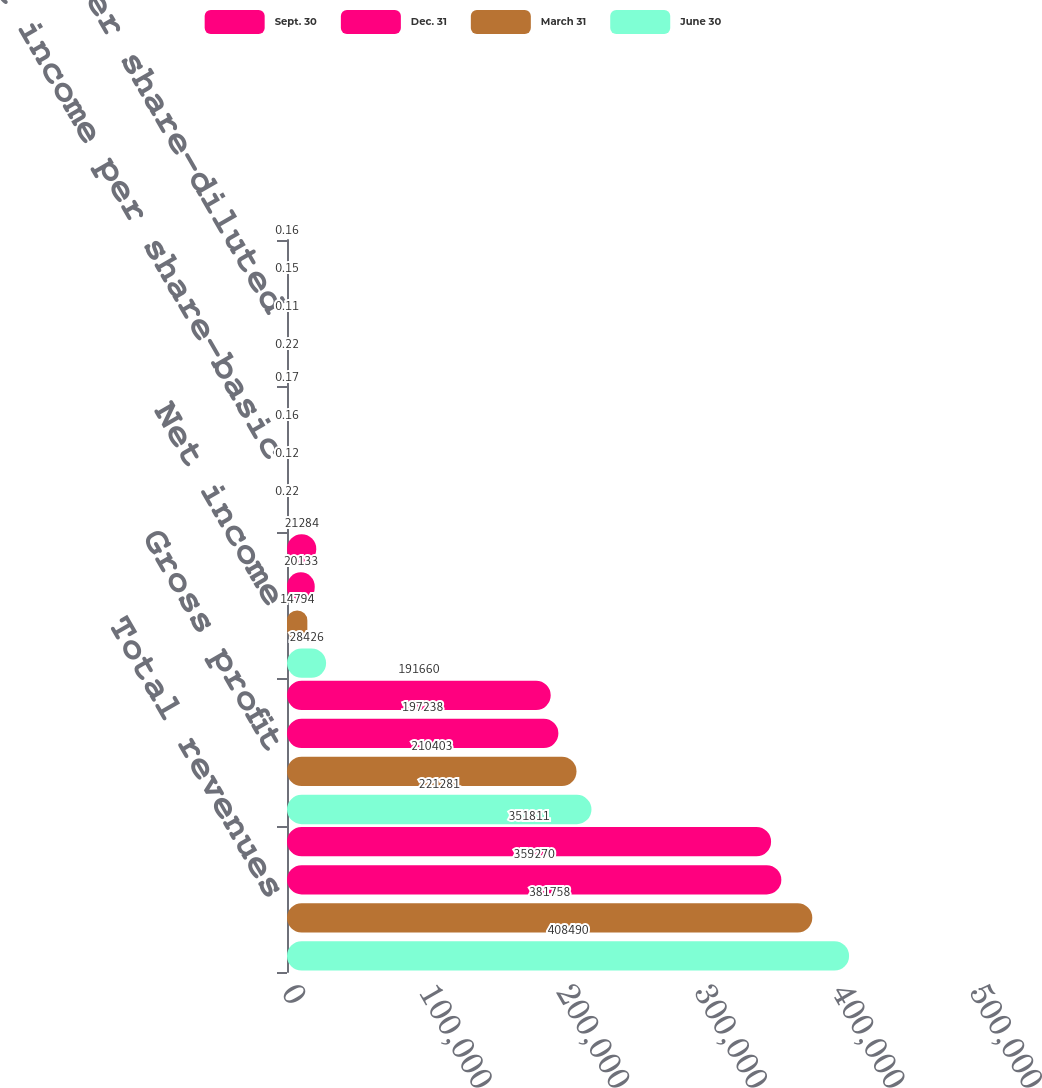Convert chart to OTSL. <chart><loc_0><loc_0><loc_500><loc_500><stacked_bar_chart><ecel><fcel>Total revenues<fcel>Gross profit<fcel>Net income<fcel>Net income per share-basic<fcel>Net income per share-diluted<nl><fcel>Sept. 30<fcel>351811<fcel>191660<fcel>21284<fcel>0.17<fcel>0.16<nl><fcel>Dec. 31<fcel>359270<fcel>197238<fcel>20133<fcel>0.16<fcel>0.15<nl><fcel>March 31<fcel>381758<fcel>210403<fcel>14794<fcel>0.12<fcel>0.11<nl><fcel>June 30<fcel>408490<fcel>221281<fcel>28426<fcel>0.22<fcel>0.22<nl></chart> 